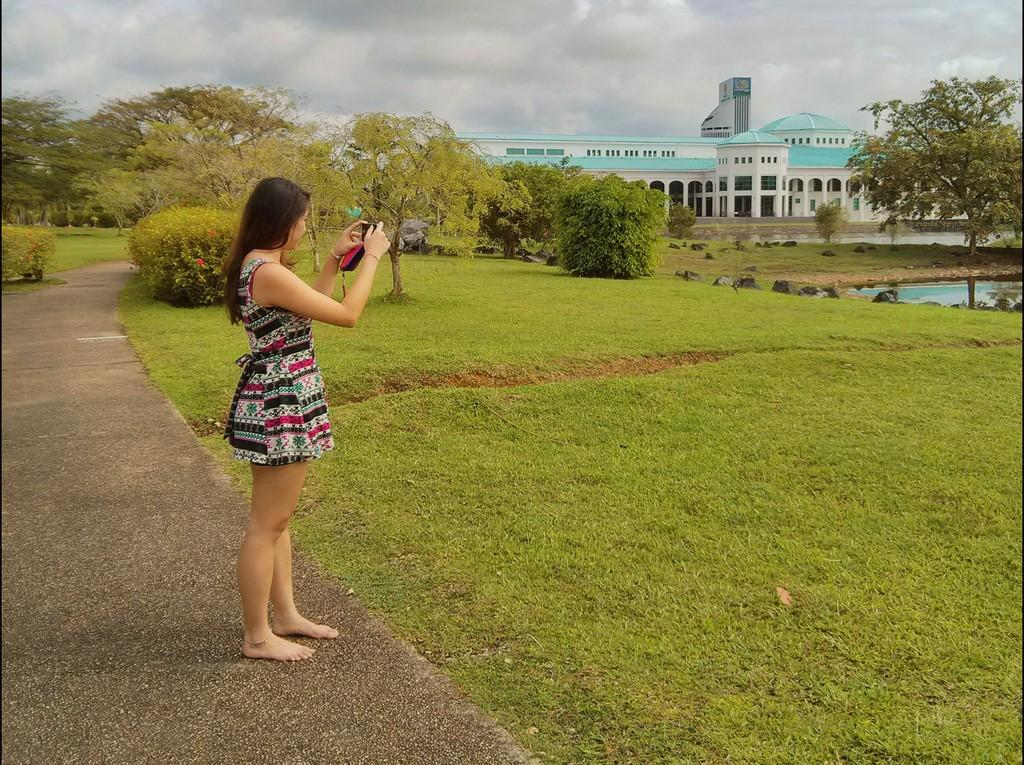What is the person in the image holding? The person is holding a camera. What can be seen in the background of the image? There is grass, plants, rocks, water, a building, trees, and the sky visible in the background of the image. What type of riddle can be solved using the celery in the image? There is no celery present in the image, so it cannot be used to solve any riddles. 